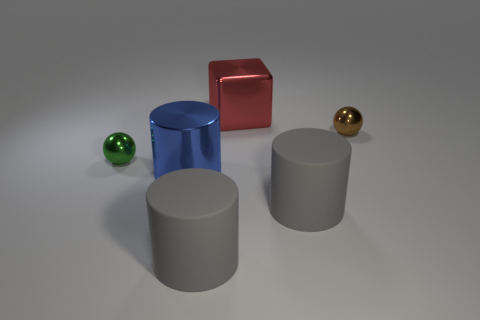Add 1 cylinders. How many objects exist? 7 Subtract all balls. How many objects are left? 4 Add 1 large gray objects. How many large gray objects are left? 3 Add 1 large gray cylinders. How many large gray cylinders exist? 3 Subtract 0 gray cubes. How many objects are left? 6 Subtract all tiny metal cylinders. Subtract all small green spheres. How many objects are left? 5 